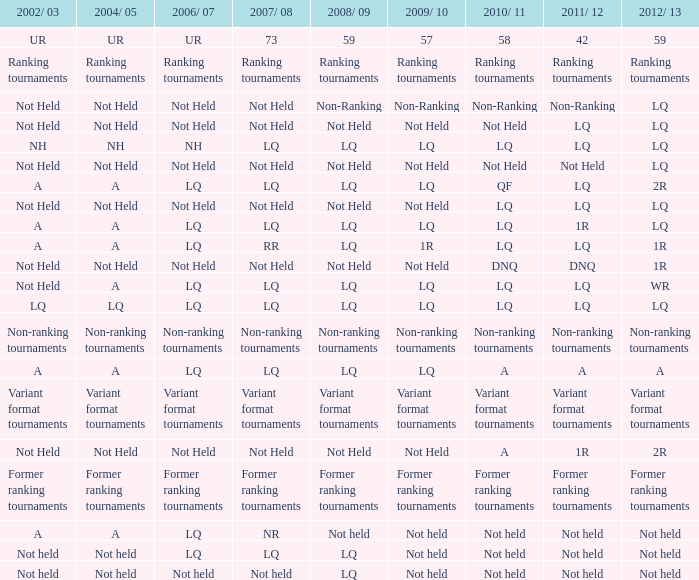Name the 2010/11 with 2004/05 of not held and 2011/12 of non-ranking Non-Ranking. 